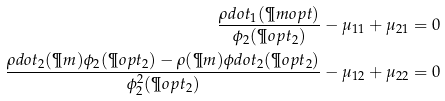<formula> <loc_0><loc_0><loc_500><loc_500>\frac { \rho d o t _ { 1 } ( \P m o p t ) } { \phi _ { 2 } ( \P o p t _ { 2 } ) } - \mu _ { 1 1 } + \mu _ { 2 1 } = 0 \\ \frac { \rho d o t _ { 2 } ( \P m ) \phi _ { 2 } ( \P o p t _ { 2 } ) - \rho ( \P m ) \phi d o t _ { 2 } ( \P o p t _ { 2 } ) } { \phi _ { 2 } ^ { 2 } ( \P o p t _ { 2 } ) } - \mu _ { 1 2 } + \mu _ { 2 2 } = 0</formula> 